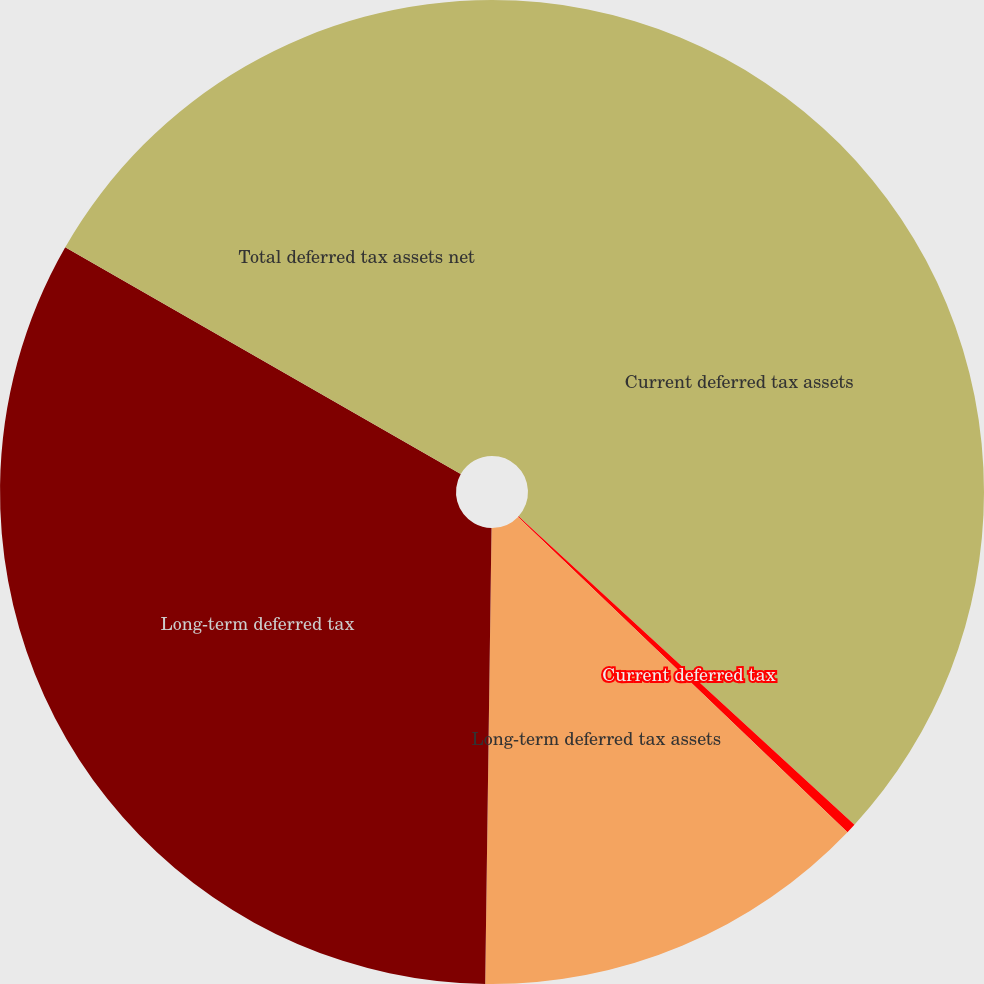Convert chart to OTSL. <chart><loc_0><loc_0><loc_500><loc_500><pie_chart><fcel>Current deferred tax assets<fcel>Current deferred tax<fcel>Long-term deferred tax assets<fcel>Long-term deferred tax<fcel>Total deferred tax assets net<nl><fcel>36.82%<fcel>0.33%<fcel>13.07%<fcel>33.07%<fcel>16.71%<nl></chart> 